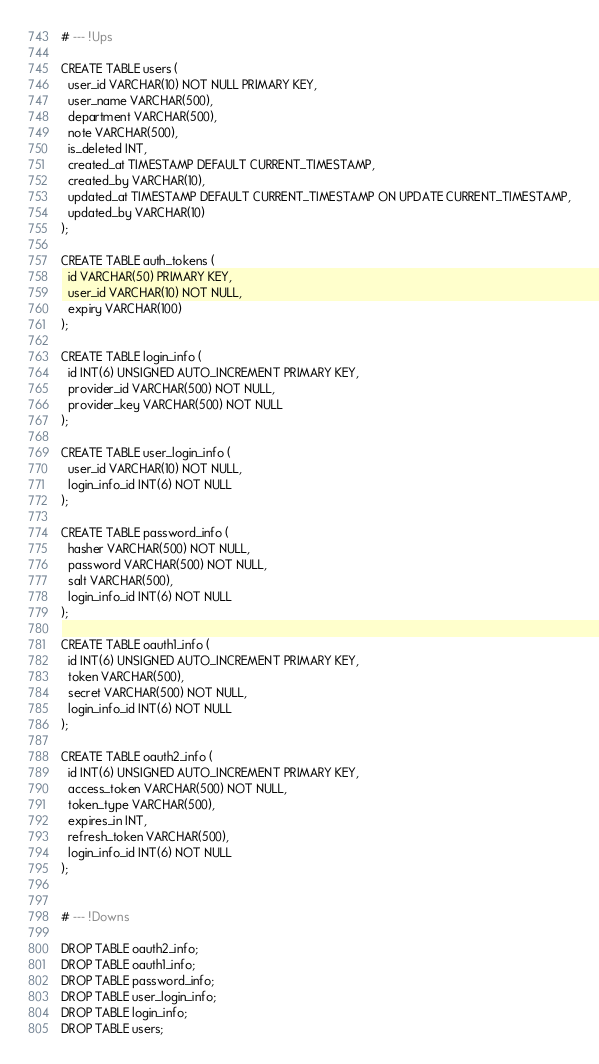<code> <loc_0><loc_0><loc_500><loc_500><_SQL_># --- !Ups

CREATE TABLE users (
  user_id VARCHAR(10) NOT NULL PRIMARY KEY,
  user_name VARCHAR(500),
  department VARCHAR(500),
  note VARCHAR(500),
  is_deleted INT,
  created_at TIMESTAMP DEFAULT CURRENT_TIMESTAMP,
  created_by VARCHAR(10),
  updated_at TIMESTAMP DEFAULT CURRENT_TIMESTAMP ON UPDATE CURRENT_TIMESTAMP,
  updated_by VARCHAR(10)
);

CREATE TABLE auth_tokens (
  id VARCHAR(50) PRIMARY KEY,
  user_id VARCHAR(10) NOT NULL,
  expiry VARCHAR(100)
);

CREATE TABLE login_info (
  id INT(6) UNSIGNED AUTO_INCREMENT PRIMARY KEY,
  provider_id VARCHAR(500) NOT NULL,
  provider_key VARCHAR(500) NOT NULL
);

CREATE TABLE user_login_info (
  user_id VARCHAR(10) NOT NULL,
  login_info_id INT(6) NOT NULL
);

CREATE TABLE password_info (
  hasher VARCHAR(500) NOT NULL,
  password VARCHAR(500) NOT NULL,
  salt VARCHAR(500),
  login_info_id INT(6) NOT NULL
);

CREATE TABLE oauth1_info (
  id INT(6) UNSIGNED AUTO_INCREMENT PRIMARY KEY,
  token VARCHAR(500),
  secret VARCHAR(500) NOT NULL,
  login_info_id INT(6) NOT NULL
);

CREATE TABLE oauth2_info (
  id INT(6) UNSIGNED AUTO_INCREMENT PRIMARY KEY,
  access_token VARCHAR(500) NOT NULL,
  token_type VARCHAR(500),
  expires_in INT,
  refresh_token VARCHAR(500),
  login_info_id INT(6) NOT NULL
);


# --- !Downs

DROP TABLE oauth2_info;
DROP TABLE oauth1_info;
DROP TABLE password_info;
DROP TABLE user_login_info;
DROP TABLE login_info;
DROP TABLE users;</code> 